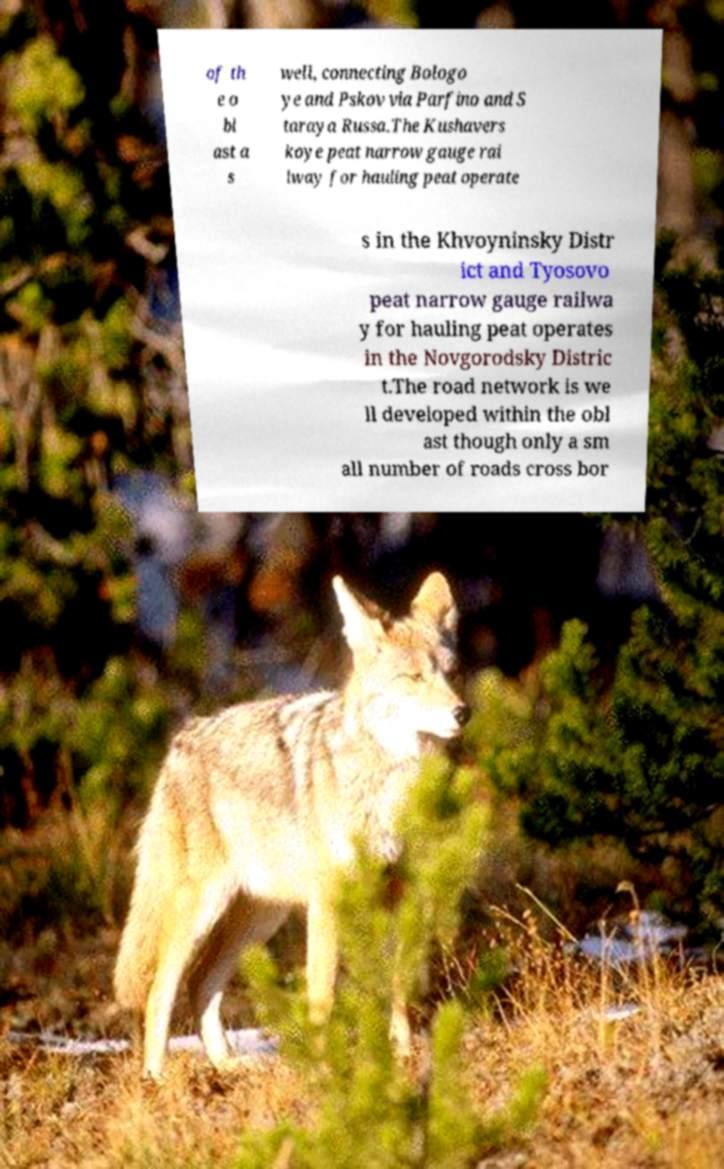Please read and relay the text visible in this image. What does it say? of th e o bl ast a s well, connecting Bologo ye and Pskov via Parfino and S taraya Russa.The Kushavers koye peat narrow gauge rai lway for hauling peat operate s in the Khvoyninsky Distr ict and Tyosovo peat narrow gauge railwa y for hauling peat operates in the Novgorodsky Distric t.The road network is we ll developed within the obl ast though only a sm all number of roads cross bor 